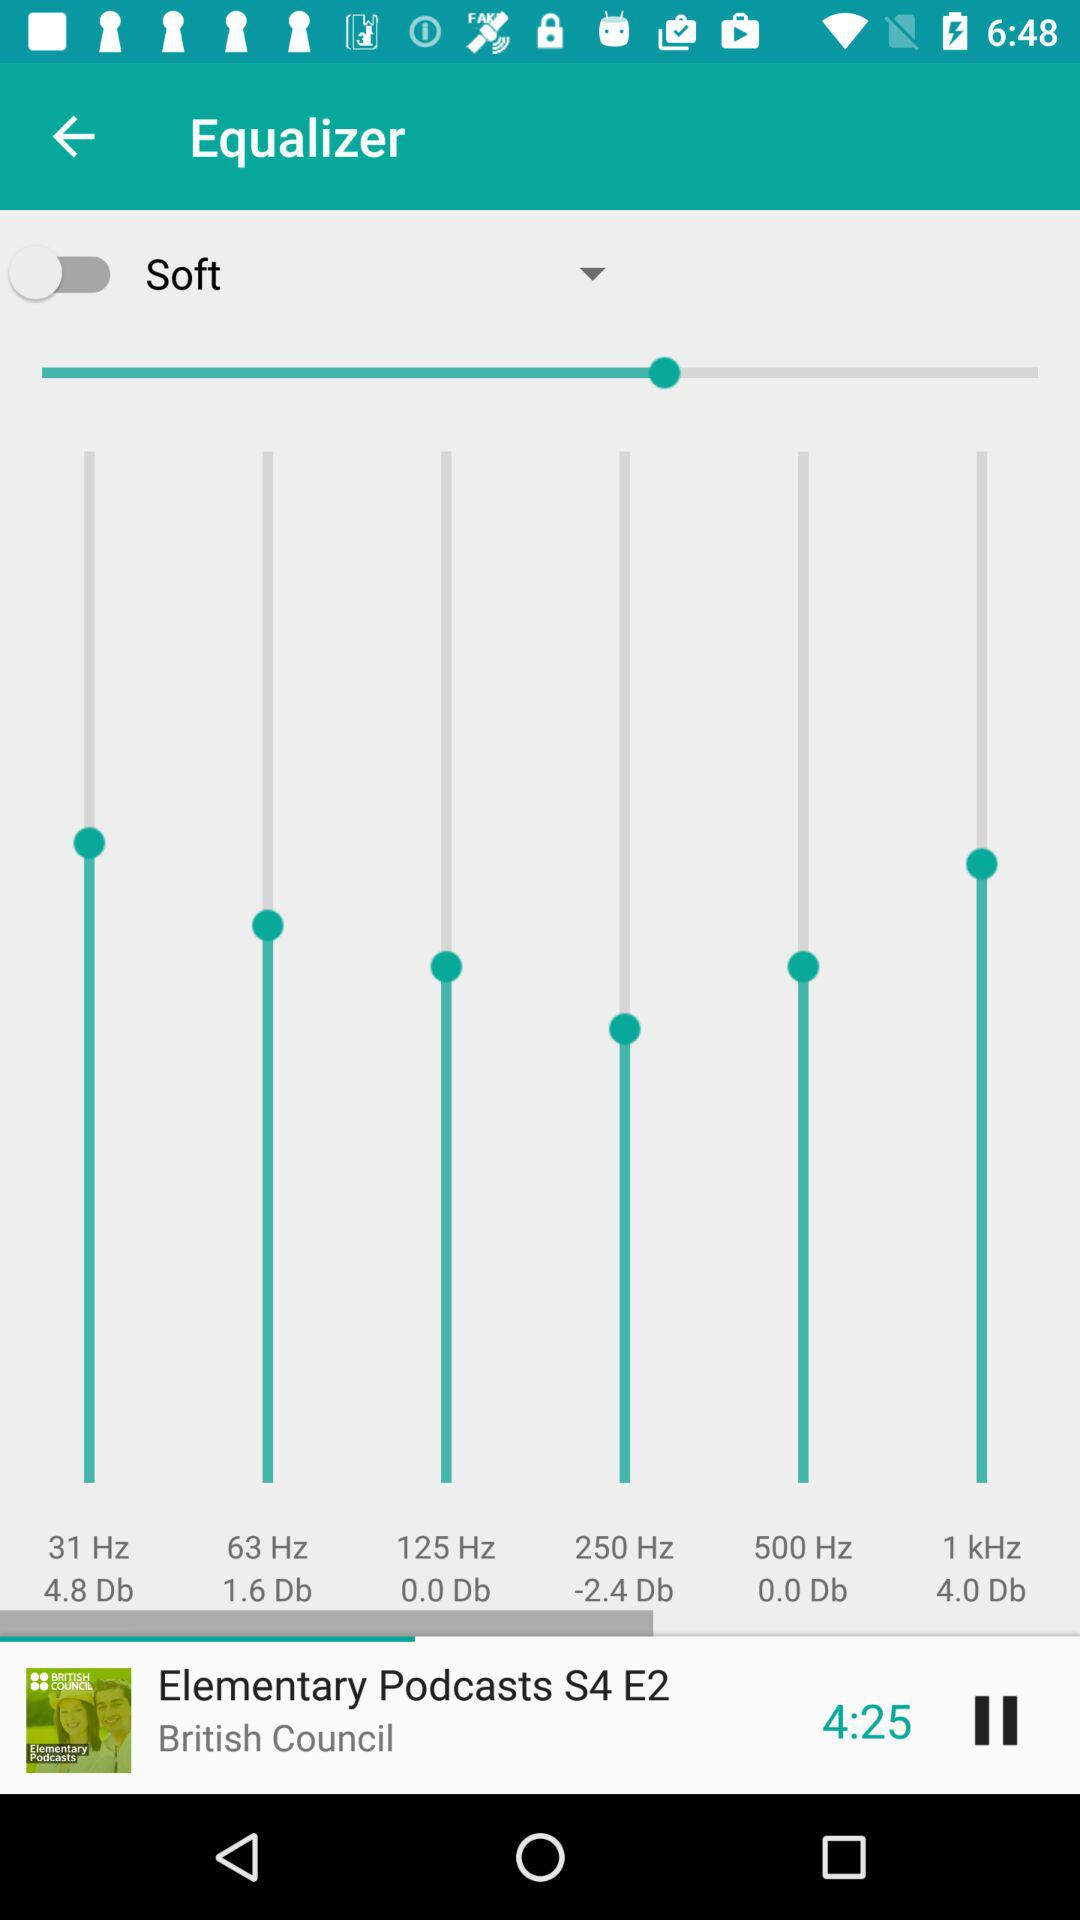What is the status of "Soft"? The status is "off". 